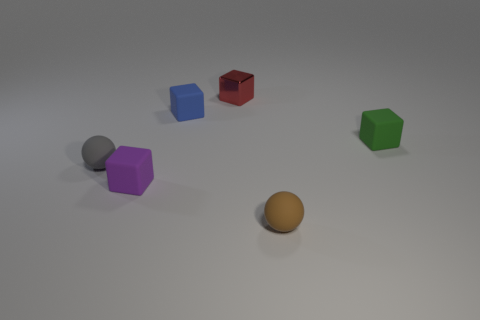What shape is the small rubber thing that is on the left side of the purple object to the left of the tiny sphere that is in front of the small gray sphere?
Make the answer very short. Sphere. What is the shape of the small green matte thing?
Make the answer very short. Cube. What is the color of the small matte sphere that is left of the metallic object?
Keep it short and to the point. Gray. Does the rubber block that is in front of the gray rubber object have the same size as the small gray thing?
Keep it short and to the point. Yes. The blue matte object that is the same shape as the green matte thing is what size?
Your response must be concise. Small. Is there any other thing that has the same size as the purple block?
Offer a very short reply. Yes. Do the red metal thing and the gray object have the same shape?
Provide a succinct answer. No. Are there fewer small green blocks in front of the purple object than brown matte spheres behind the tiny red thing?
Provide a succinct answer. No. There is a blue rubber block; how many rubber balls are on the left side of it?
Keep it short and to the point. 1. There is a thing that is on the left side of the small purple block; does it have the same shape as the purple rubber object on the right side of the gray thing?
Provide a succinct answer. No. 